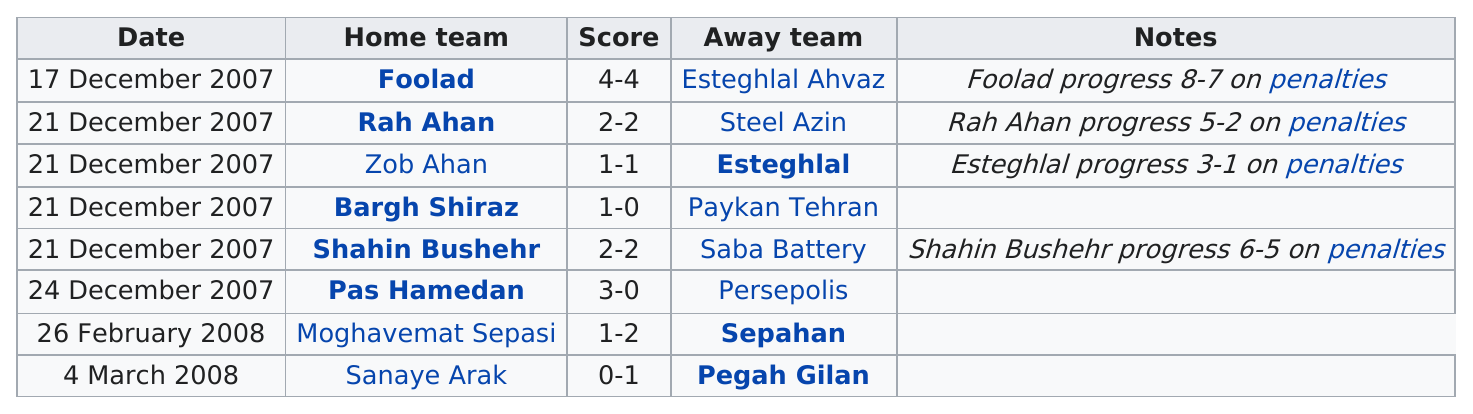Give some essential details in this illustration. The home team member did not score on March 4, 2008. The score of Pegah Gilan is better than Sanaye Arak. With a score of 3-1, Esteghlal secured the most points in the game against Zob Ahan. On average, the score of all home team members for all dates is 1.75. Both Foolad and Esteghlal Ahvaz teams scored 4 goals each, making them exceptional performers. 